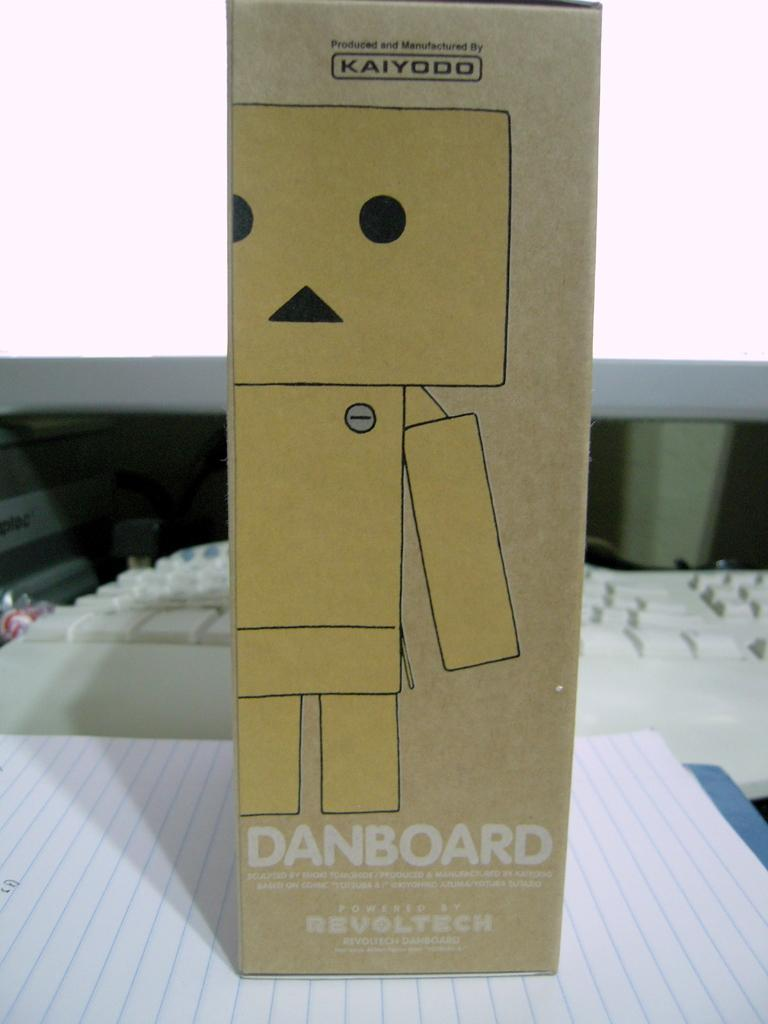<image>
Offer a succinct explanation of the picture presented. A brown paper box with a robot on it produced by Kaiyodo. 